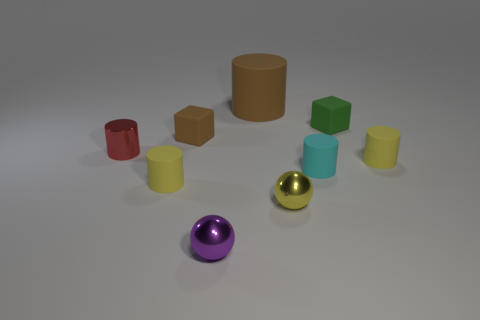What number of things are either green rubber objects or tiny cyan matte things?
Provide a succinct answer. 2. There is a yellow object that is both behind the yellow shiny object and on the right side of the brown rubber cube; what is its shape?
Offer a very short reply. Cylinder. Does the tiny yellow cylinder left of the small brown matte thing have the same material as the brown cylinder?
Keep it short and to the point. Yes. What number of objects are either small green objects or tiny cylinders that are on the right side of the purple metal sphere?
Offer a very short reply. 3. There is another big cylinder that is made of the same material as the cyan cylinder; what color is it?
Your answer should be very brief. Brown. How many other objects have the same material as the tiny green thing?
Keep it short and to the point. 5. What number of gray rubber cubes are there?
Provide a short and direct response. 0. Do the cylinder that is behind the red metallic object and the block left of the large rubber cylinder have the same color?
Make the answer very short. Yes. There is a tiny cyan matte thing; how many small red cylinders are to the left of it?
Your response must be concise. 1. What is the material of the cube that is the same color as the big object?
Make the answer very short. Rubber. 